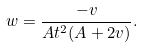<formula> <loc_0><loc_0><loc_500><loc_500>w = \frac { - v } { A t ^ { 2 } ( A + 2 v ) } .</formula> 